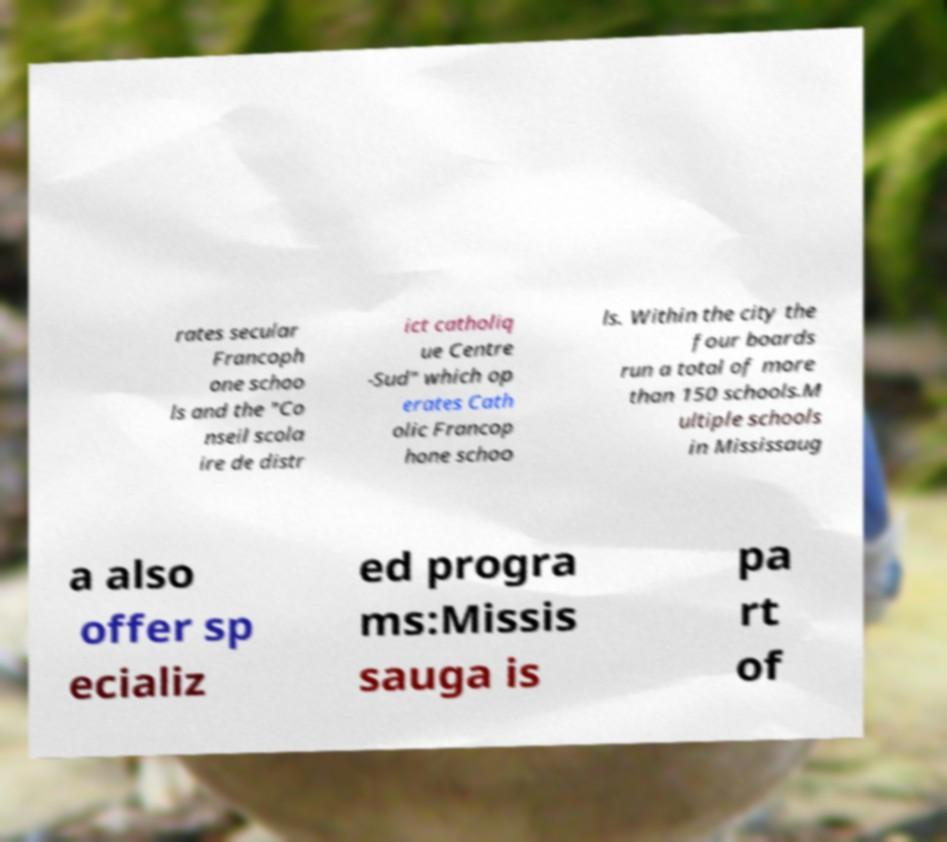Can you accurately transcribe the text from the provided image for me? rates secular Francoph one schoo ls and the "Co nseil scola ire de distr ict catholiq ue Centre -Sud" which op erates Cath olic Francop hone schoo ls. Within the city the four boards run a total of more than 150 schools.M ultiple schools in Mississaug a also offer sp ecializ ed progra ms:Missis sauga is pa rt of 